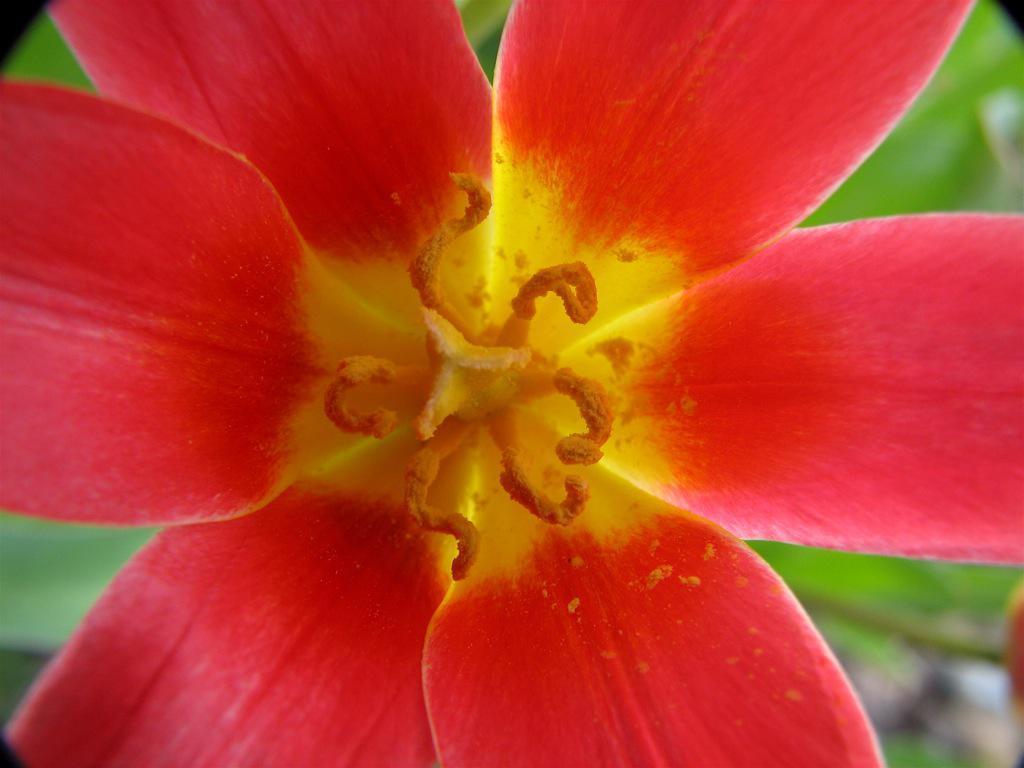In one or two sentences, can you explain what this image depicts? In this I can see a beautiful flower with pollen grains in yellow color. 